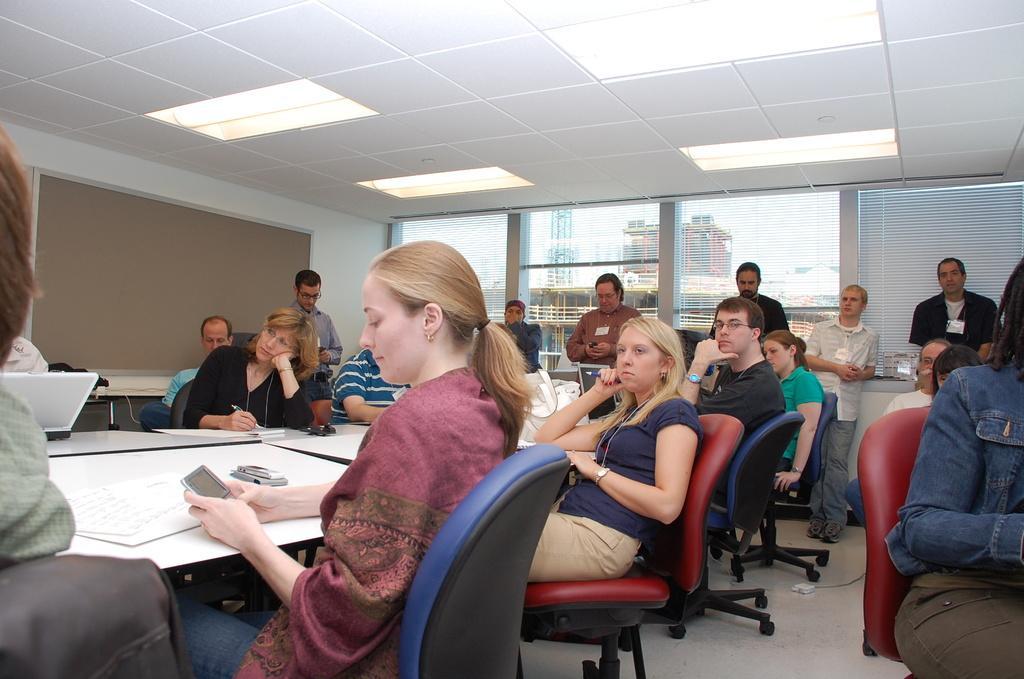Can you describe this image briefly? Woman sitting on the chair around the table,these are lights,person standing. 